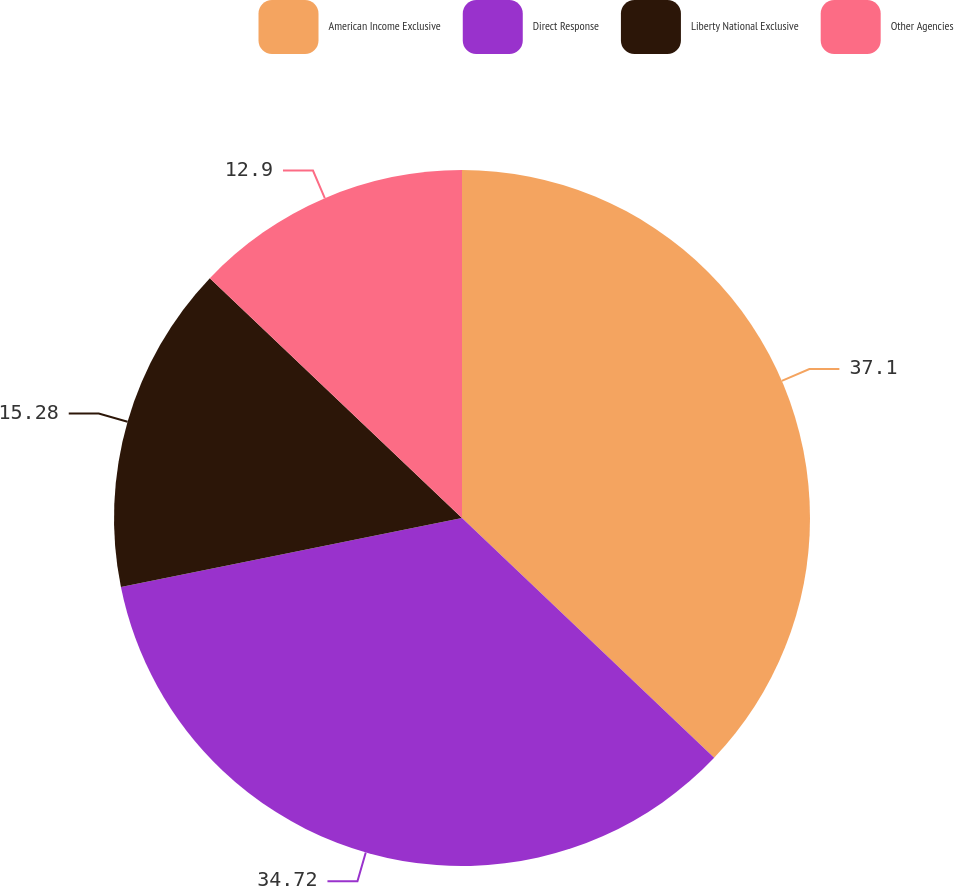Convert chart to OTSL. <chart><loc_0><loc_0><loc_500><loc_500><pie_chart><fcel>American Income Exclusive<fcel>Direct Response<fcel>Liberty National Exclusive<fcel>Other Agencies<nl><fcel>37.1%<fcel>34.72%<fcel>15.28%<fcel>12.9%<nl></chart> 